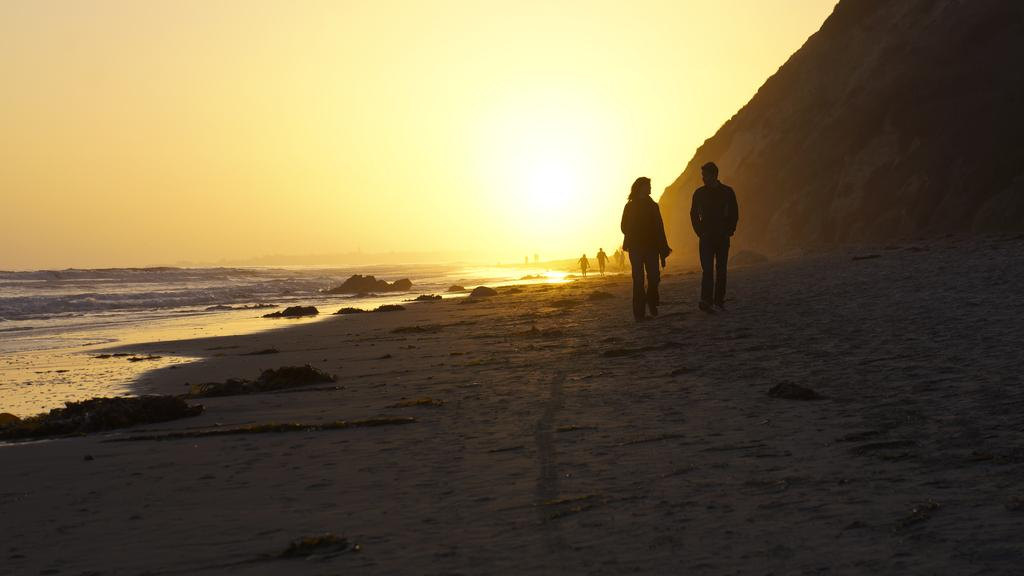What is happening on the ground in the image? There are people on the ground in the image. What can be seen on the left side of the image? There is water visible on the left side of the image. What is visible in the background of the image? The sky is visible in the image. What is located on the right side of the image? There is a mountain on the right side of the image. What celestial body is visible in the background of the image? The sun is visible in the background of the image. What shape is the maid taking in the image? There is no maid present in the image. What type of camp can be seen in the image? There is no camp present in the image. 